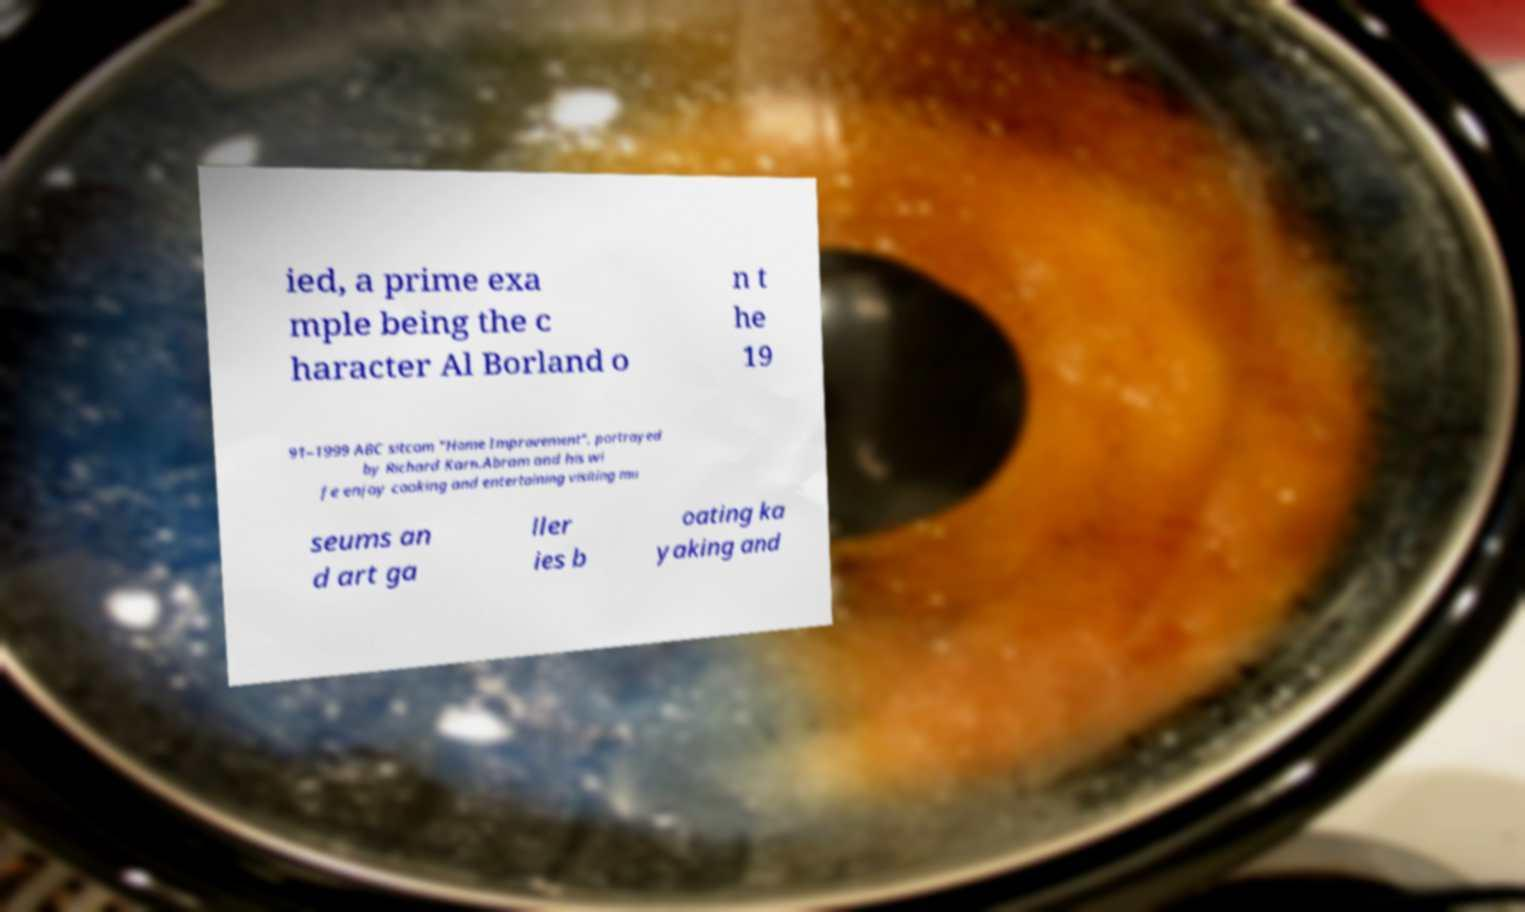Please read and relay the text visible in this image. What does it say? ied, a prime exa mple being the c haracter Al Borland o n t he 19 91–1999 ABC sitcom "Home Improvement", portrayed by Richard Karn.Abram and his wi fe enjoy cooking and entertaining visiting mu seums an d art ga ller ies b oating ka yaking and 